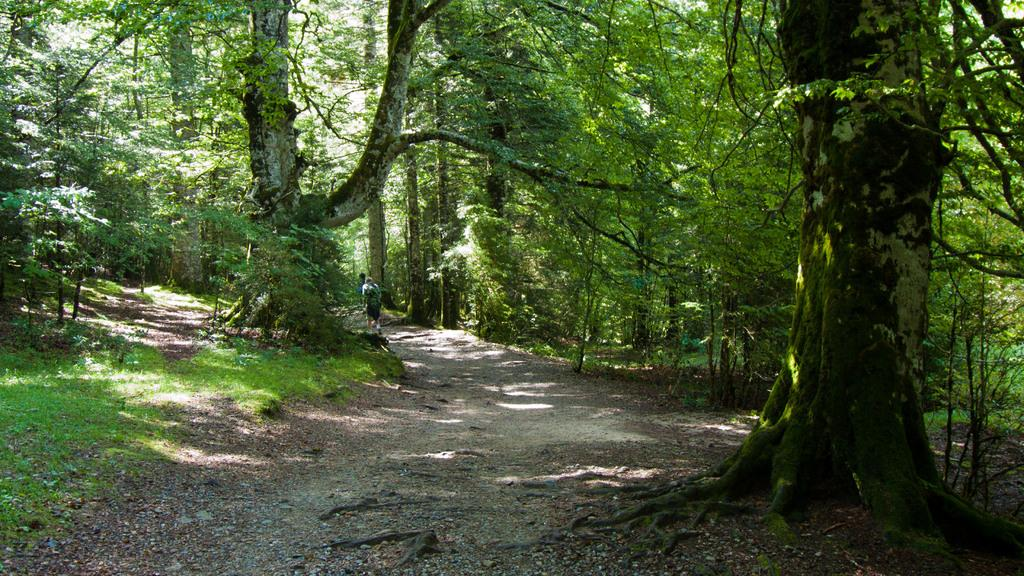What type of vegetation can be seen in the image? There are trees in the image. What is the color of the grass in the image? The grass in the image is green. What is a feature of the landscape in the image? There is a path in the image. Are there any people present in the image? Yes, there is a person in the image. What type of books can be seen on the trees in the image? There are no books present in the image; only trees are visible. What color is the ink used by the wren in the image? There is no wren present in the image, and birds do not use ink. 